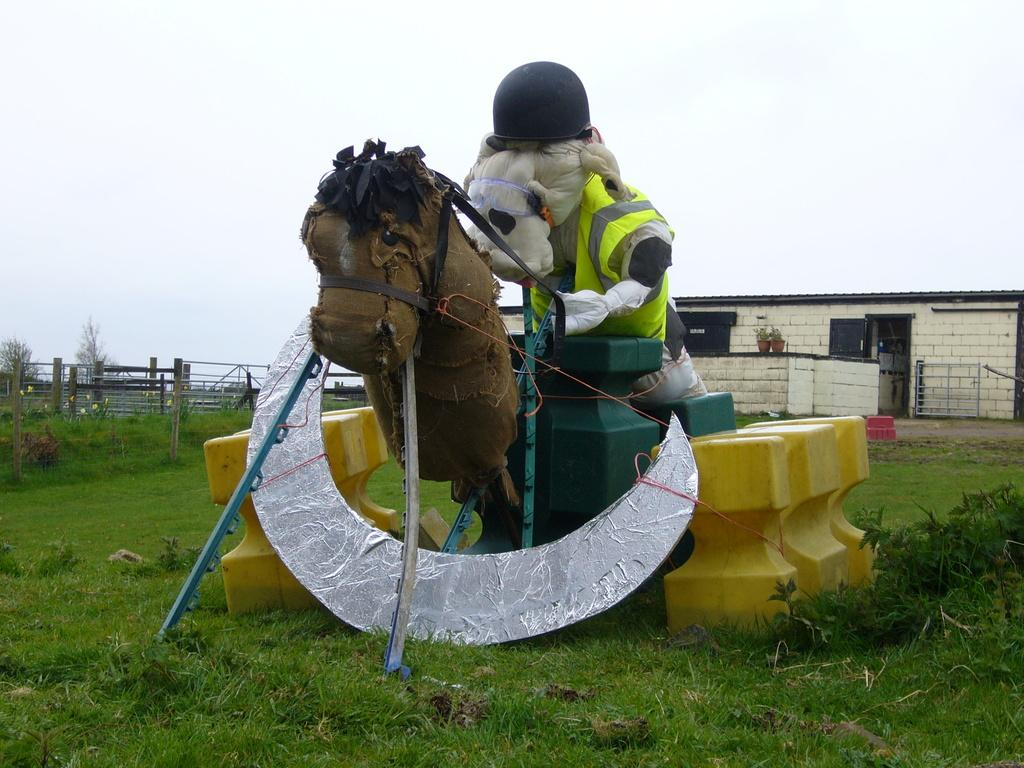What type of objects are depicted as sculptures in the image? There are sculptures of animals in the image. What type of vegetation can be seen in the image? There is grass visible in the image. What type of structure is present in the image? There is a house in the image. What type of barrier can be seen in the image? There is a fence in the image. What type of natural elements are present in the image? There are trees in the image. What part of the natural environment is visible in the image? The sky is visible in the image. What type of bone is visible in the image? There is no bone present in the image. What type of spark can be seen in the image? There is no spark present in the image. 